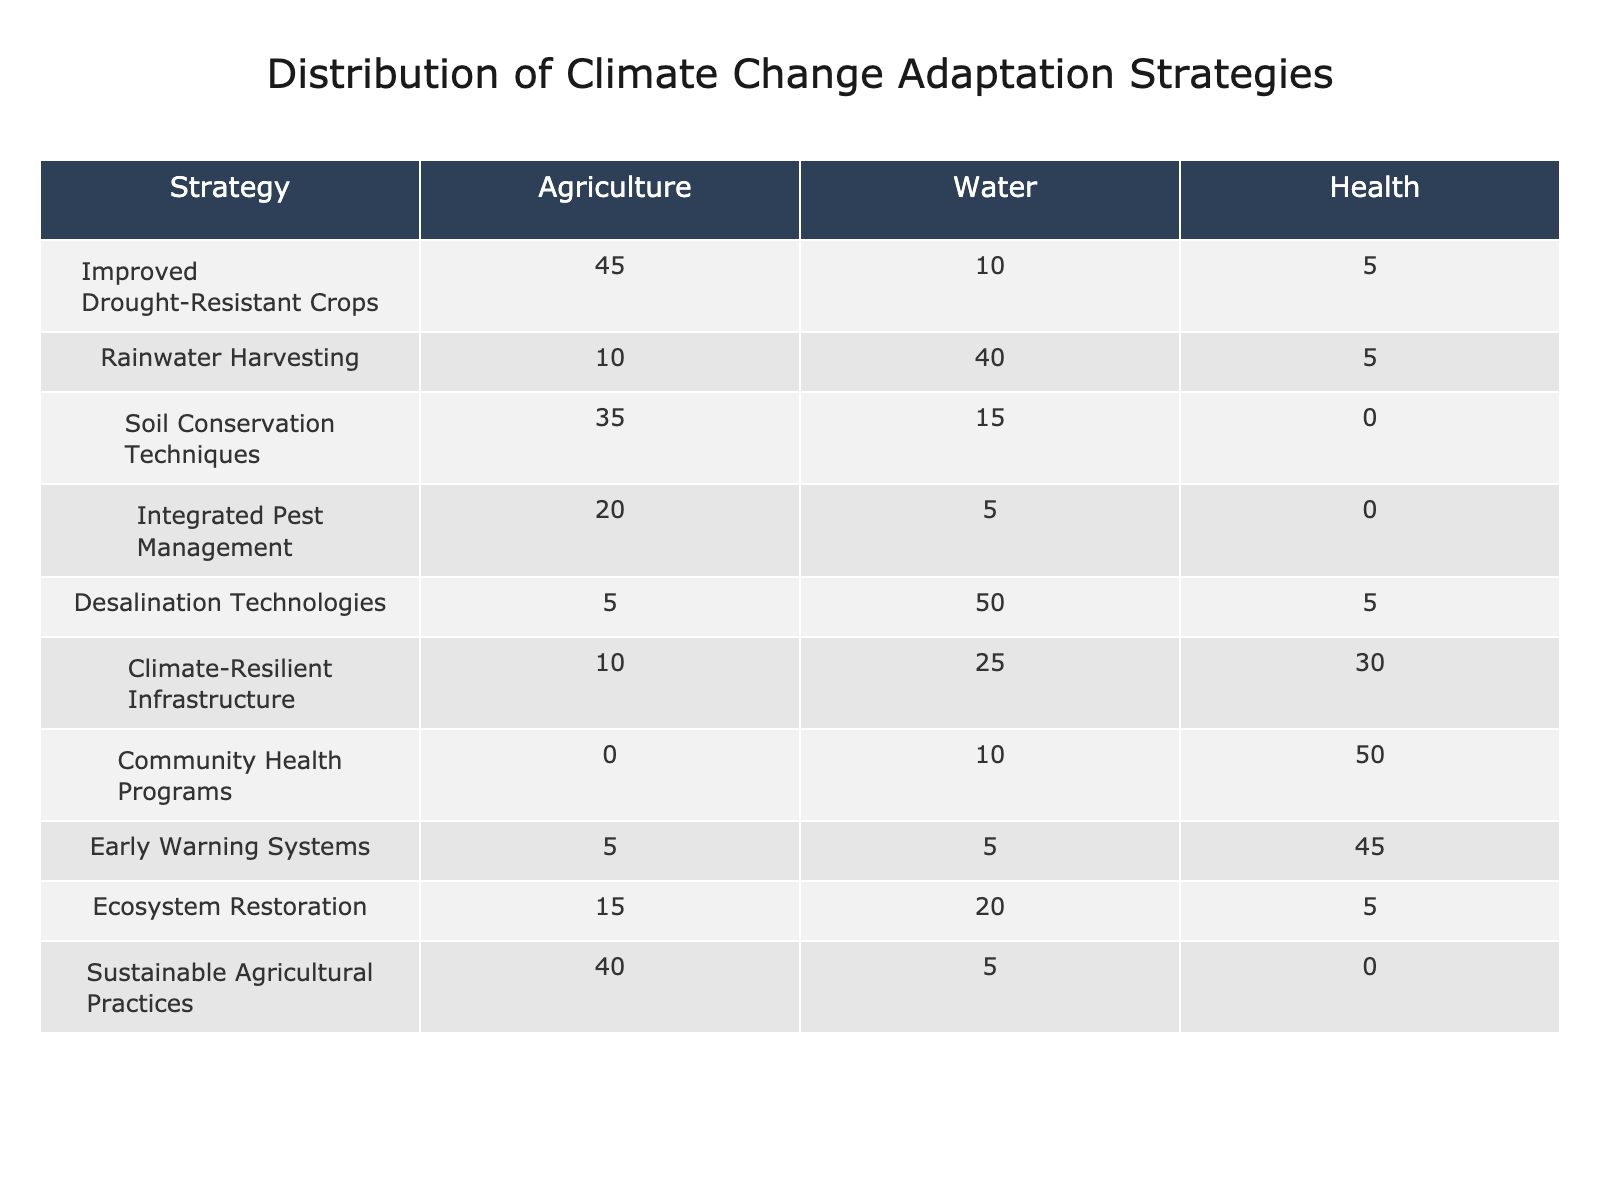What strategy has the highest distribution in agriculture? Improved Drought-Resistant Crops has a value of 45, which is higher than any other strategy listed under agriculture.
Answer: Improved Drought-Resistant Crops What is the total number of adaptation strategies applied in the water sector? Summing the values for the water sector gives (10 + 40 + 15 + 5 + 50 + 25 + 10 + 5 + 20 + 5) = 180.
Answer: 180 Is the use of Climate-Resilient Infrastructure more prevalent in the health sector than in agriculture? The value for Climate-Resilient Infrastructure in health is 30, and for agriculture, it is 10. Since 30 > 10, the statement is true.
Answer: Yes What is the average distribution of strategies in the health sector? Sum the health sector values: (5 + 5 + 0 + 0 + 5 + 30 + 50 + 45 + 5 + 0) = 100. There are 10 strategies, so the average is 100/10 = 10.
Answer: 10 Which sector shows the least investment in Soil Conservation Techniques? The value for Soil Conservation Techniques in the health sector is 0, which is less than its values in agriculture (35) and water (15).
Answer: Health What is the combined total of adaptation strategies for agriculture and health? The total for agriculture is 45 + 10 + 35 + 20 + 5 + 10 + 0 + 5 + 15 + 40 = 180. The total for health is 5 + 5 + 0 + 0 + 5 + 30 + 50 + 45 + 5 + 0 = 100. Combining these gives 180 + 100 = 280.
Answer: 280 Are there any strategies in the health sector that have a distribution value of zero? The table lists Integrated Pest Management, Soil Conservation Techniques, and Sustainable Agricultural Practices as having a distribution of 0 in the health sector. Therefore, the statement is true.
Answer: Yes Which adaptation strategy with the highest value in the water sector has the lowest value in the agriculture sector? Desalination Technologies has the highest value in the water sector (50), but only 5 in agriculture, making it the lowest among all top strategies in agriculture.
Answer: Desalination Technologies What is the difference between the highest and lowest strategy values in the water sector? The highest value in the water sector is for Desalination Technologies (50) and the lowest is for Integrated Pest Management (5). Thus, the difference is 50 - 5 = 45.
Answer: 45 